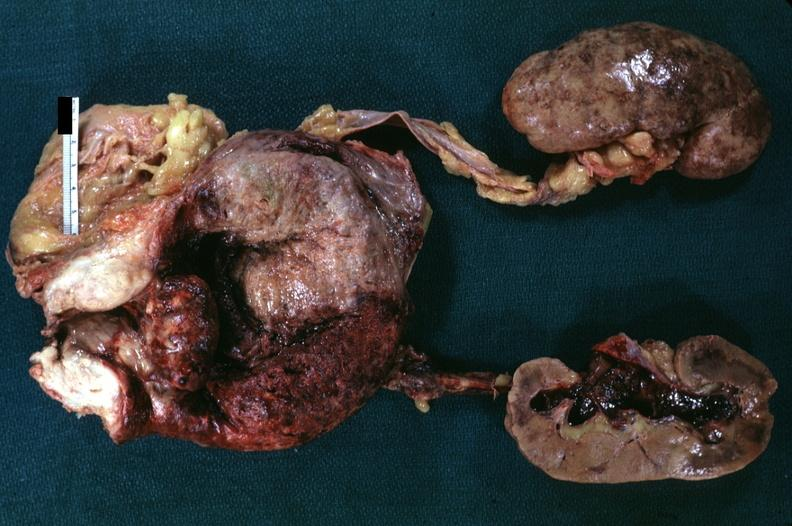s prostate present?
Answer the question using a single word or phrase. Yes 